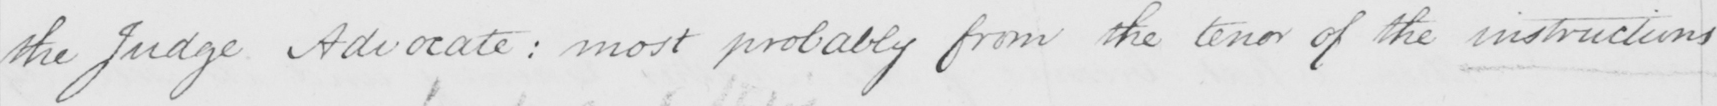Transcribe the text shown in this historical manuscript line. the Judge Advocate :  most probably from the tenor of the instructions 